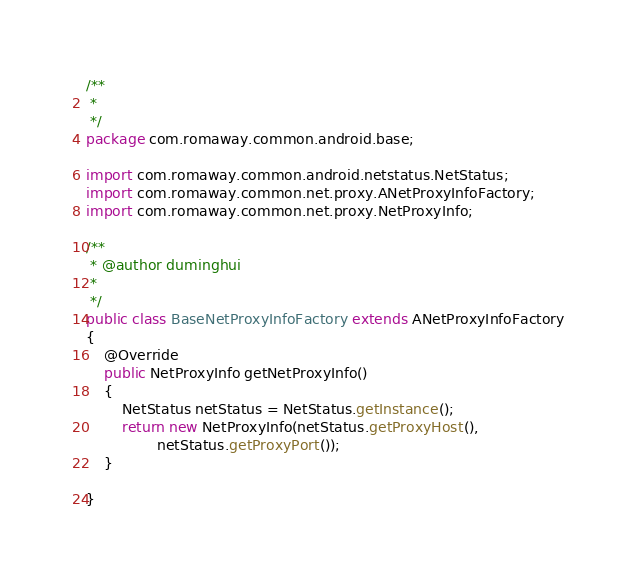<code> <loc_0><loc_0><loc_500><loc_500><_Java_>/**
 * 
 */
package com.romaway.common.android.base;

import com.romaway.common.android.netstatus.NetStatus;
import com.romaway.common.net.proxy.ANetProxyInfoFactory;
import com.romaway.common.net.proxy.NetProxyInfo;

/**
 * @author duminghui
 * 
 */
public class BaseNetProxyInfoFactory extends ANetProxyInfoFactory
{
	@Override
	public NetProxyInfo getNetProxyInfo()
	{
		NetStatus netStatus = NetStatus.getInstance();
		return new NetProxyInfo(netStatus.getProxyHost(),
		        netStatus.getProxyPort());
	}

}
</code> 